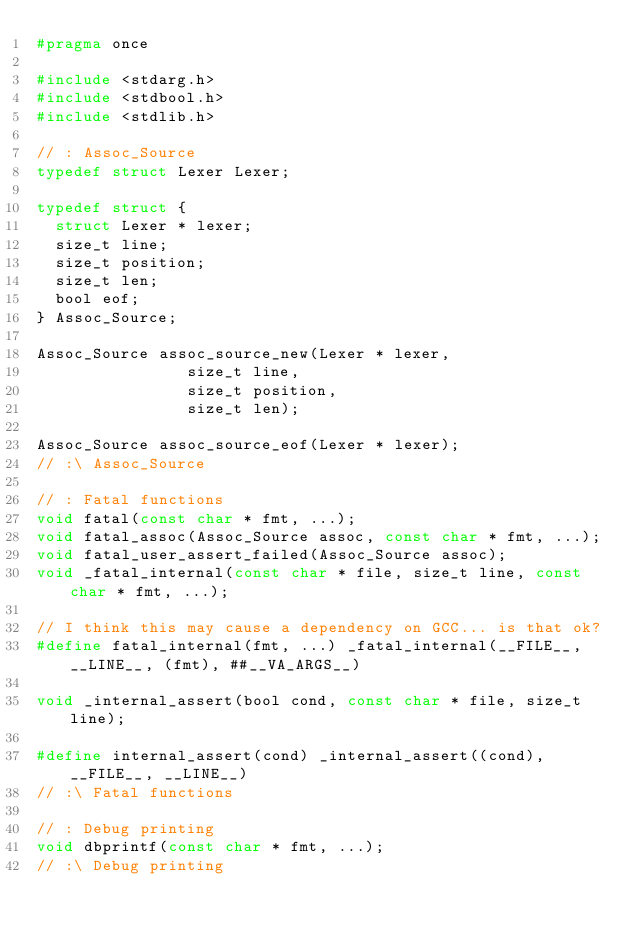<code> <loc_0><loc_0><loc_500><loc_500><_C_>#pragma once

#include <stdarg.h>
#include <stdbool.h>
#include <stdlib.h>

// : Assoc_Source
typedef struct Lexer Lexer;

typedef struct {
	struct Lexer * lexer;
	size_t line;
	size_t position;
	size_t len;
	bool eof;
} Assoc_Source;

Assoc_Source assoc_source_new(Lexer * lexer,
							  size_t line,
							  size_t position,
							  size_t len);

Assoc_Source assoc_source_eof(Lexer * lexer);
// :\ Assoc_Source

// : Fatal functions
void fatal(const char * fmt, ...);
void fatal_assoc(Assoc_Source assoc, const char * fmt, ...);
void fatal_user_assert_failed(Assoc_Source assoc);
void _fatal_internal(const char * file, size_t line, const char * fmt, ...);

// I think this may cause a dependency on GCC... is that ok?
#define fatal_internal(fmt, ...) _fatal_internal(__FILE__, __LINE__, (fmt), ##__VA_ARGS__)

void _internal_assert(bool cond, const char * file, size_t line);

#define internal_assert(cond) _internal_assert((cond), __FILE__, __LINE__)
// :\ Fatal functions

// : Debug printing
void dbprintf(const char * fmt, ...);
// :\ Debug printing
</code> 